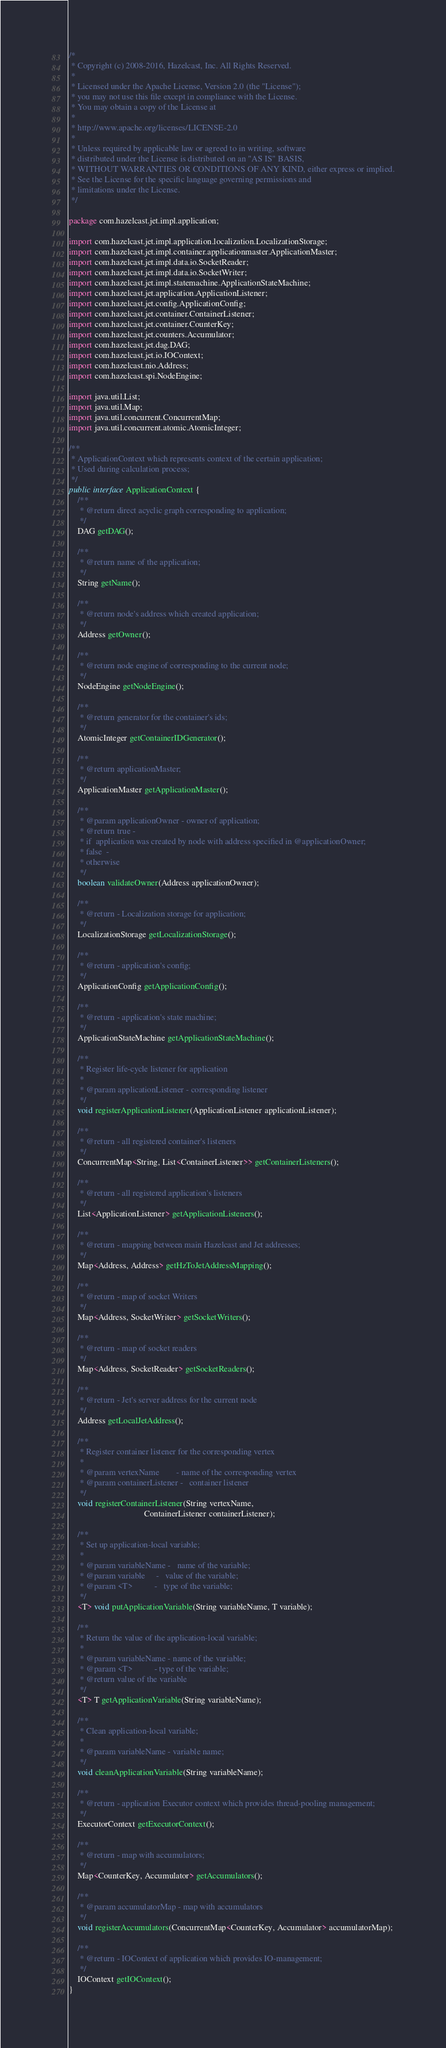Convert code to text. <code><loc_0><loc_0><loc_500><loc_500><_Java_>/*
 * Copyright (c) 2008-2016, Hazelcast, Inc. All Rights Reserved.
 *
 * Licensed under the Apache License, Version 2.0 (the "License");
 * you may not use this file except in compliance with the License.
 * You may obtain a copy of the License at
 *
 * http://www.apache.org/licenses/LICENSE-2.0
 *
 * Unless required by applicable law or agreed to in writing, software
 * distributed under the License is distributed on an "AS IS" BASIS,
 * WITHOUT WARRANTIES OR CONDITIONS OF ANY KIND, either express or implied.
 * See the License for the specific language governing permissions and
 * limitations under the License.
 */

package com.hazelcast.jet.impl.application;

import com.hazelcast.jet.impl.application.localization.LocalizationStorage;
import com.hazelcast.jet.impl.container.applicationmaster.ApplicationMaster;
import com.hazelcast.jet.impl.data.io.SocketReader;
import com.hazelcast.jet.impl.data.io.SocketWriter;
import com.hazelcast.jet.impl.statemachine.ApplicationStateMachine;
import com.hazelcast.jet.application.ApplicationListener;
import com.hazelcast.jet.config.ApplicationConfig;
import com.hazelcast.jet.container.ContainerListener;
import com.hazelcast.jet.container.CounterKey;
import com.hazelcast.jet.counters.Accumulator;
import com.hazelcast.jet.dag.DAG;
import com.hazelcast.jet.io.IOContext;
import com.hazelcast.nio.Address;
import com.hazelcast.spi.NodeEngine;

import java.util.List;
import java.util.Map;
import java.util.concurrent.ConcurrentMap;
import java.util.concurrent.atomic.AtomicInteger;

/**
 * ApplicationContext which represents context of the certain application;
 * Used during calculation process;
 */
public interface ApplicationContext {
    /**
     * @return direct acyclic graph corresponding to application;
     */
    DAG getDAG();

    /**
     * @return name of the application;
     */
    String getName();

    /**
     * @return node's address which created application;
     */
    Address getOwner();

    /**
     * @return node engine of corresponding to the current node;
     */
    NodeEngine getNodeEngine();

    /**
     * @return generator for the container's ids;
     */
    AtomicInteger getContainerIDGenerator();

    /**
     * @return applicationMaster;
     */
    ApplicationMaster getApplicationMaster();

    /**
     * @param applicationOwner - owner of application;
     * @return true -
     * if  application was created by node with address specified in @applicationOwner;
     * false  -
     * otherwise
     */
    boolean validateOwner(Address applicationOwner);

    /**
     * @return - Localization storage for application;
     */
    LocalizationStorage getLocalizationStorage();

    /**
     * @return - application's config;
     */
    ApplicationConfig getApplicationConfig();

    /**
     * @return - application's state machine;
     */
    ApplicationStateMachine getApplicationStateMachine();

    /**
     * Register life-cycle listener for application
     *
     * @param applicationListener - corresponding listener
     */
    void registerApplicationListener(ApplicationListener applicationListener);

    /**
     * @return - all registered container's listeners
     */
    ConcurrentMap<String, List<ContainerListener>> getContainerListeners();

    /**
     * @return - all registered application's listeners
     */
    List<ApplicationListener> getApplicationListeners();

    /**
     * @return - mapping between main Hazelcast and Jet addresses;
     */
    Map<Address, Address> getHzToJetAddressMapping();

    /**
     * @return - map of socket Writers
     */
    Map<Address, SocketWriter> getSocketWriters();

    /**
     * @return - map of socket readers
     */
    Map<Address, SocketReader> getSocketReaders();

    /**
     * @return - Jet's server address for the current node
     */
    Address getLocalJetAddress();

    /**
     * Register container listener for the corresponding vertex
     *
     * @param vertexName        - name of the corresponding vertex
     * @param containerListener -   container listener
     */
    void registerContainerListener(String vertexName,
                                   ContainerListener containerListener);

    /**
     * Set up application-local variable;
     *
     * @param variableName -   name of the variable;
     * @param variable     -   value of the variable;
     * @param <T>          -   type of the variable;
     */
    <T> void putApplicationVariable(String variableName, T variable);

    /**
     * Return the value of the application-local variable;
     *
     * @param variableName - name of the variable;
     * @param <T>          - type of the variable;
     * @return value of the variable
     */
    <T> T getApplicationVariable(String variableName);

    /**
     * Clean application-local variable;
     *
     * @param variableName - variable name;
     */
    void cleanApplicationVariable(String variableName);

    /**
     * @return - application Executor context which provides thread-pooling management;
     */
    ExecutorContext getExecutorContext();

    /**
     * @return - map with accumulators;
     */
    Map<CounterKey, Accumulator> getAccumulators();

    /**
     * @param accumulatorMap - map with accumulators
     */
    void registerAccumulators(ConcurrentMap<CounterKey, Accumulator> accumulatorMap);

    /**
     * @return - IOContext of application which provides IO-management;
     */
    IOContext getIOContext();
}
</code> 